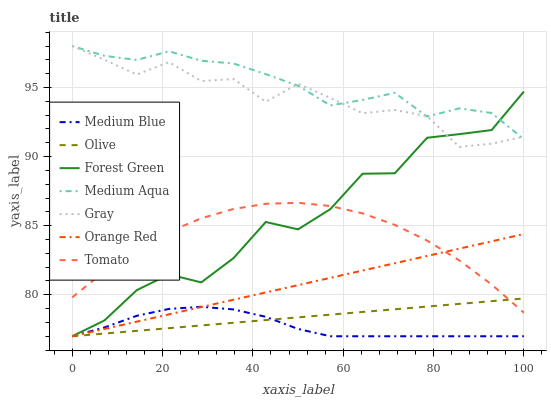Does Medium Blue have the minimum area under the curve?
Answer yes or no. Yes. Does Medium Aqua have the maximum area under the curve?
Answer yes or no. Yes. Does Gray have the minimum area under the curve?
Answer yes or no. No. Does Gray have the maximum area under the curve?
Answer yes or no. No. Is Olive the smoothest?
Answer yes or no. Yes. Is Forest Green the roughest?
Answer yes or no. Yes. Is Gray the smoothest?
Answer yes or no. No. Is Gray the roughest?
Answer yes or no. No. Does Medium Blue have the lowest value?
Answer yes or no. Yes. Does Gray have the lowest value?
Answer yes or no. No. Does Medium Aqua have the highest value?
Answer yes or no. Yes. Does Medium Blue have the highest value?
Answer yes or no. No. Is Medium Blue less than Tomato?
Answer yes or no. Yes. Is Medium Aqua greater than Tomato?
Answer yes or no. Yes. Does Gray intersect Medium Aqua?
Answer yes or no. Yes. Is Gray less than Medium Aqua?
Answer yes or no. No. Is Gray greater than Medium Aqua?
Answer yes or no. No. Does Medium Blue intersect Tomato?
Answer yes or no. No. 